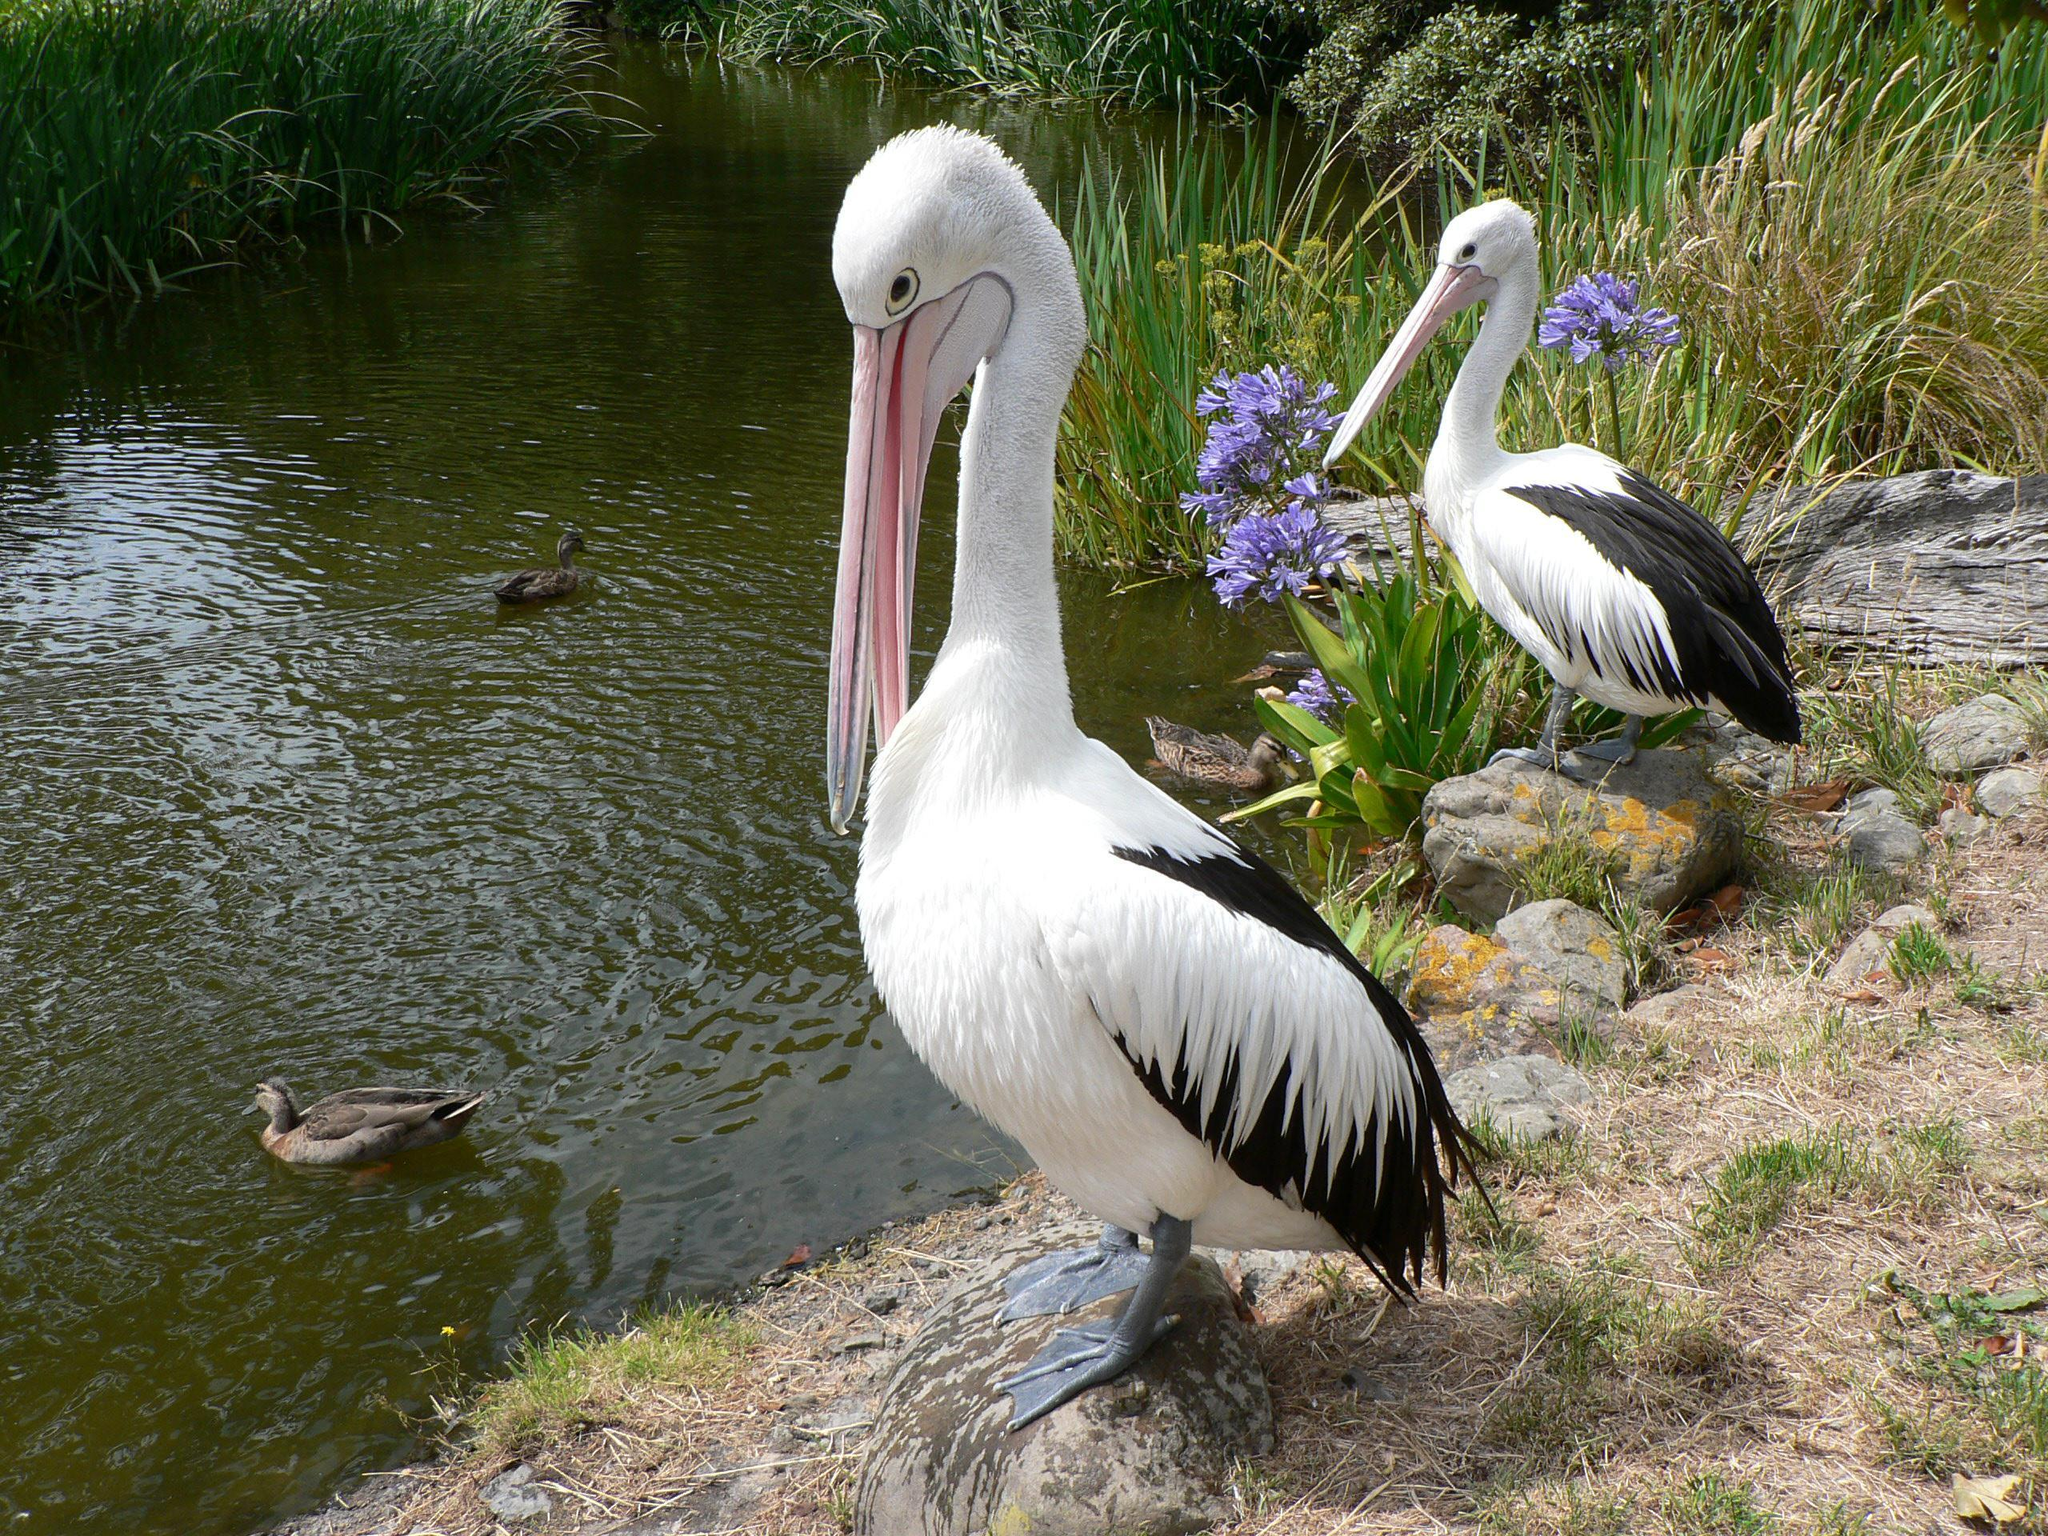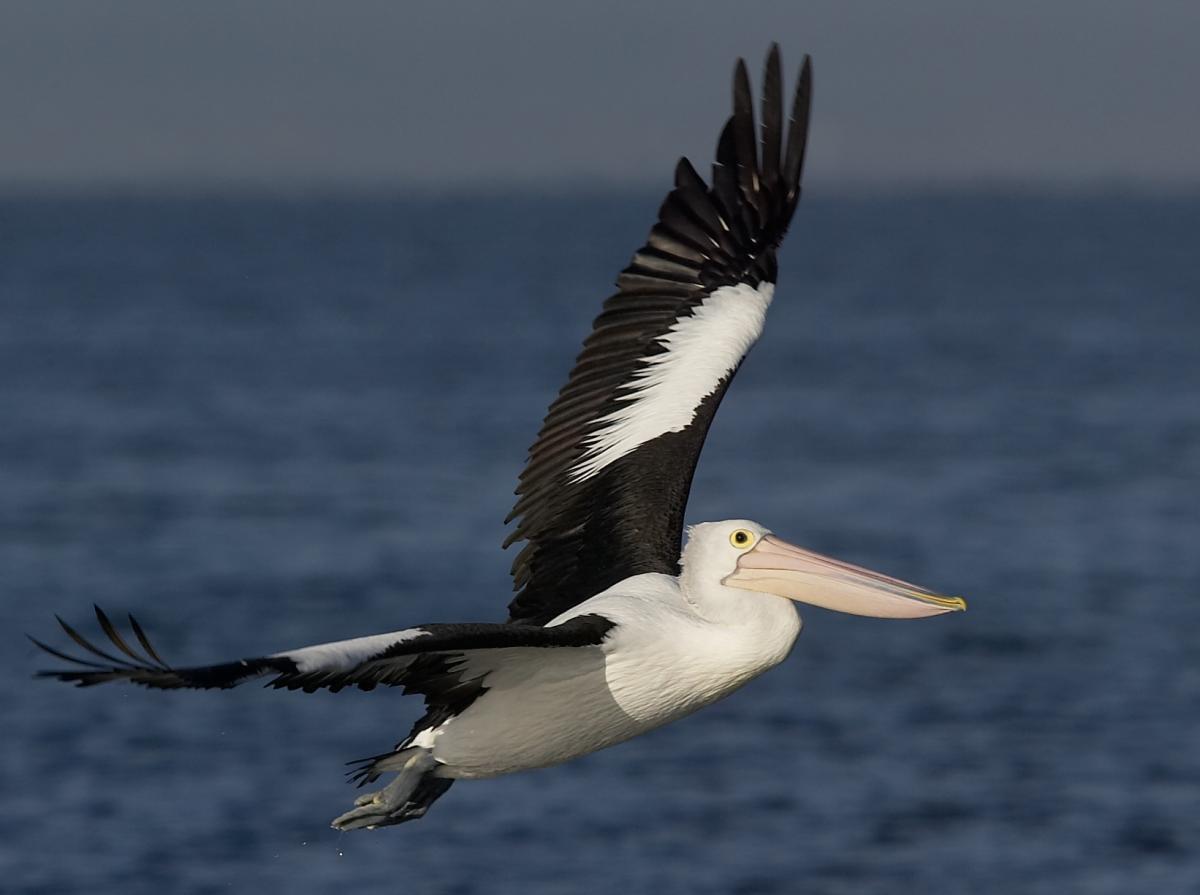The first image is the image on the left, the second image is the image on the right. Given the left and right images, does the statement "There is a pelican flying in the air." hold true? Answer yes or no. Yes. 